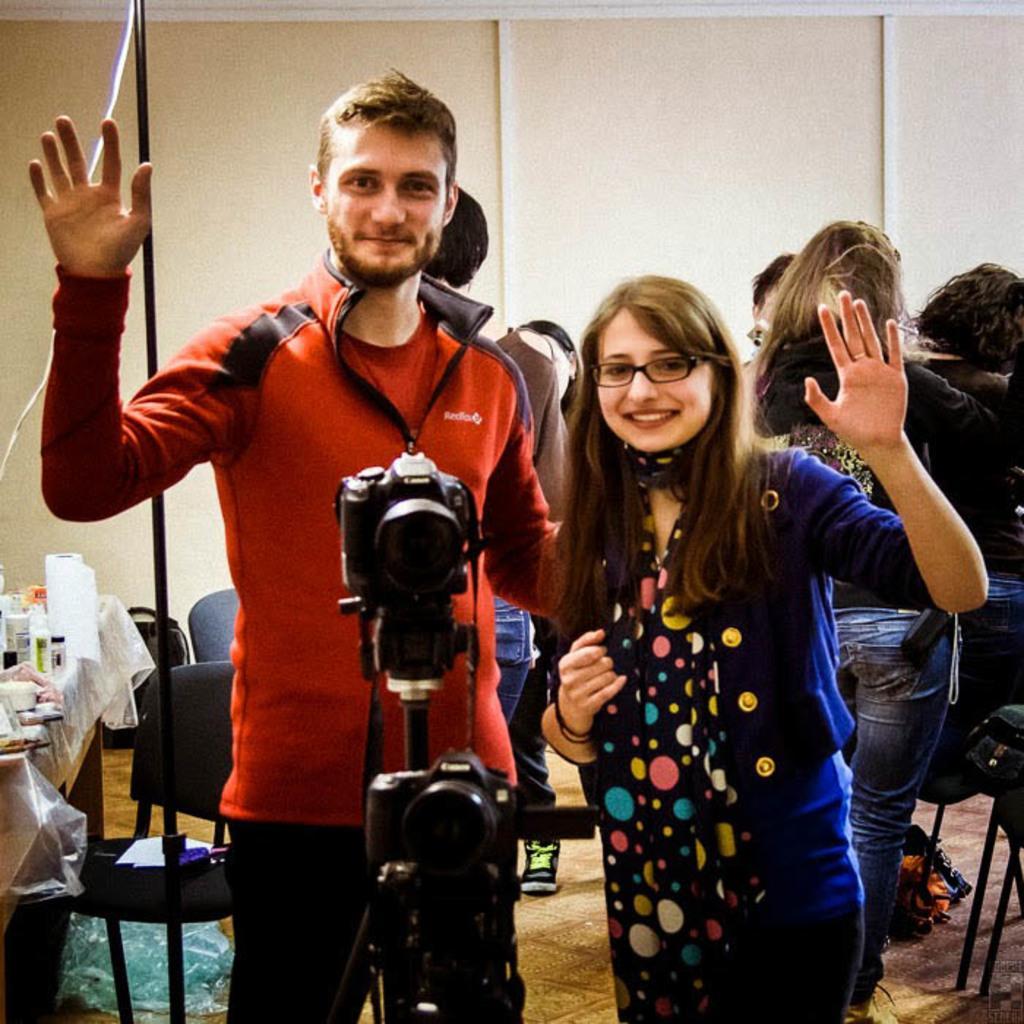In one or two sentences, can you explain what this image depicts? In the given image i can see a people,camera,chairs and some objects on the table. 